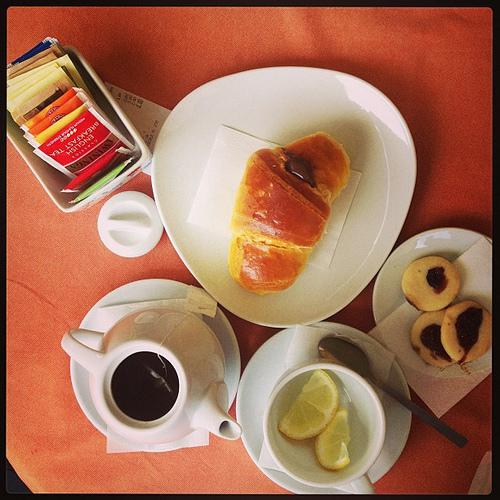Question: what color are the plates?
Choices:
A. White.
B. Green.
C. Blue.
D. Yellow.
Answer with the letter. Answer: A Question: where is the plates?
Choices:
A. On the table cloth.
B. On the table.
C. On the counter.
D. In the dishwasher.
Answer with the letter. Answer: A Question: what color is the drink in the cup?
Choices:
A. Black.
B. Brown.
C. White.
D. Yellow.
Answer with the letter. Answer: A Question: where are the cups?
Choices:
A. On the counter.
B. On the table.
C. In the cupboard.
D. On the plates.
Answer with the letter. Answer: D 